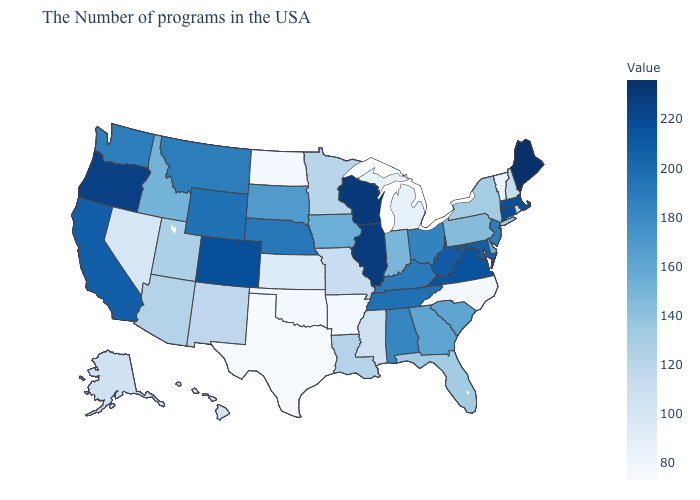Which states have the lowest value in the USA?
Write a very short answer. Texas. Does Maine have the highest value in the USA?
Concise answer only. Yes. Which states have the lowest value in the USA?
Concise answer only. Texas. Does Texas have the lowest value in the USA?
Keep it brief. Yes. 